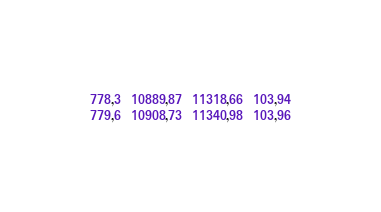Convert code to text. <code><loc_0><loc_0><loc_500><loc_500><_SML_>778,3  10889,87  11318,66  103,94
779,6  10908,73  11340,98  103,96</code> 